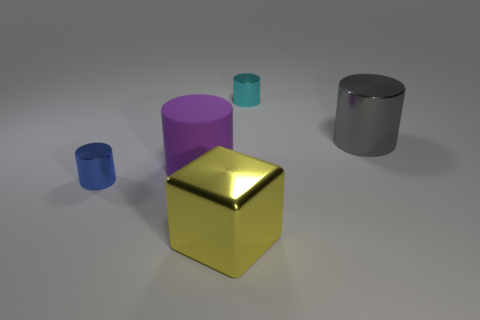Subtract all large purple cylinders. How many cylinders are left? 3 Subtract all purple cylinders. How many cylinders are left? 3 Add 5 yellow spheres. How many objects exist? 10 Subtract all cubes. How many objects are left? 4 Subtract all red cylinders. Subtract all gray spheres. How many cylinders are left? 4 Add 5 large purple rubber cylinders. How many large purple rubber cylinders exist? 6 Subtract 1 cyan cylinders. How many objects are left? 4 Subtract all brown blocks. Subtract all cylinders. How many objects are left? 1 Add 5 cylinders. How many cylinders are left? 9 